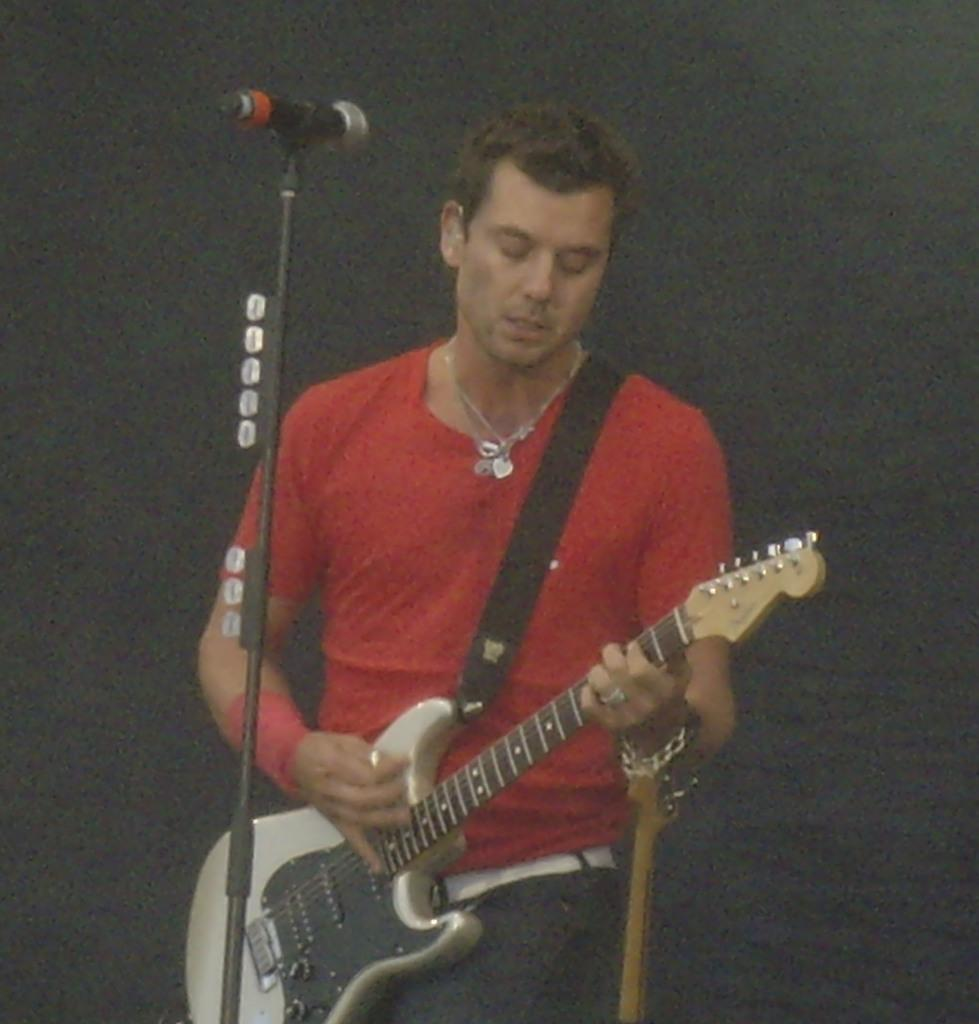What is the man in the image doing? The man is playing a guitar in the image. What object is present in the image that is commonly used for amplifying sound? There is a microphone in the image. What type of mint is the man chewing while playing the guitar in the image? There is no mint present in the image, and the man is not chewing anything. 